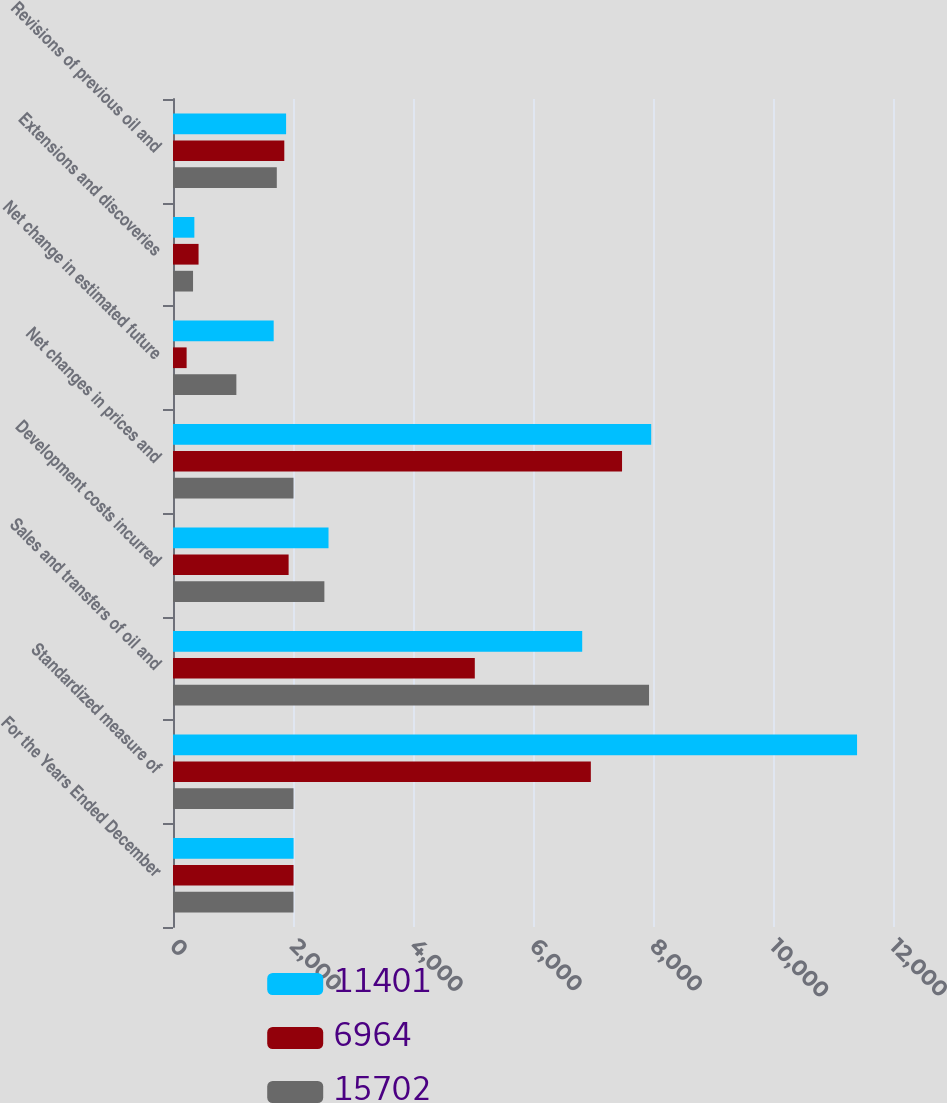<chart> <loc_0><loc_0><loc_500><loc_500><stacked_bar_chart><ecel><fcel>For the Years Ended December<fcel>Standardized measure of<fcel>Sales and transfers of oil and<fcel>Development costs incurred<fcel>Net changes in prices and<fcel>Net change in estimated future<fcel>Extensions and discoveries<fcel>Revisions of previous oil and<nl><fcel>11401<fcel>2010<fcel>11401<fcel>6820<fcel>2592<fcel>7970<fcel>1678<fcel>356<fcel>1885<nl><fcel>6964<fcel>2009<fcel>6964<fcel>5030<fcel>1927<fcel>7484<fcel>227<fcel>426<fcel>1855<nl><fcel>15702<fcel>2008<fcel>2008.5<fcel>7934<fcel>2523<fcel>2008.5<fcel>1056<fcel>334<fcel>1730<nl></chart> 